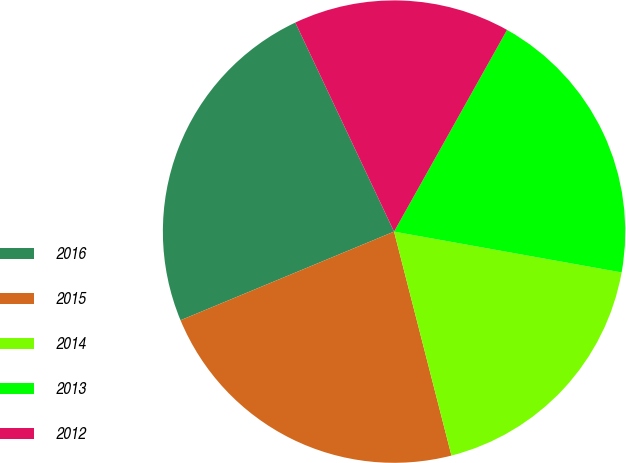Convert chart to OTSL. <chart><loc_0><loc_0><loc_500><loc_500><pie_chart><fcel>2016<fcel>2015<fcel>2014<fcel>2013<fcel>2012<nl><fcel>24.24%<fcel>22.73%<fcel>18.18%<fcel>19.7%<fcel>15.15%<nl></chart> 